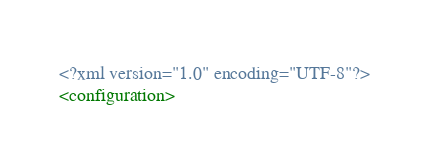<code> <loc_0><loc_0><loc_500><loc_500><_XML_><?xml version="1.0" encoding="UTF-8"?>
<configuration></code> 